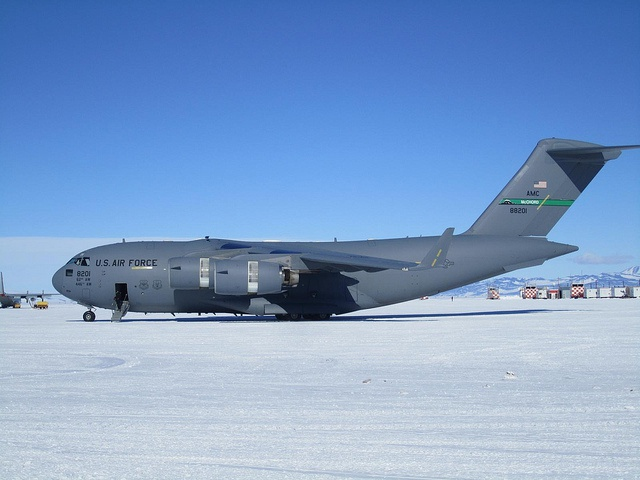Describe the objects in this image and their specific colors. I can see airplane in blue, gray, black, and navy tones, airplane in blue, gray, darkblue, and black tones, and truck in blue, tan, khaki, maroon, and gray tones in this image. 